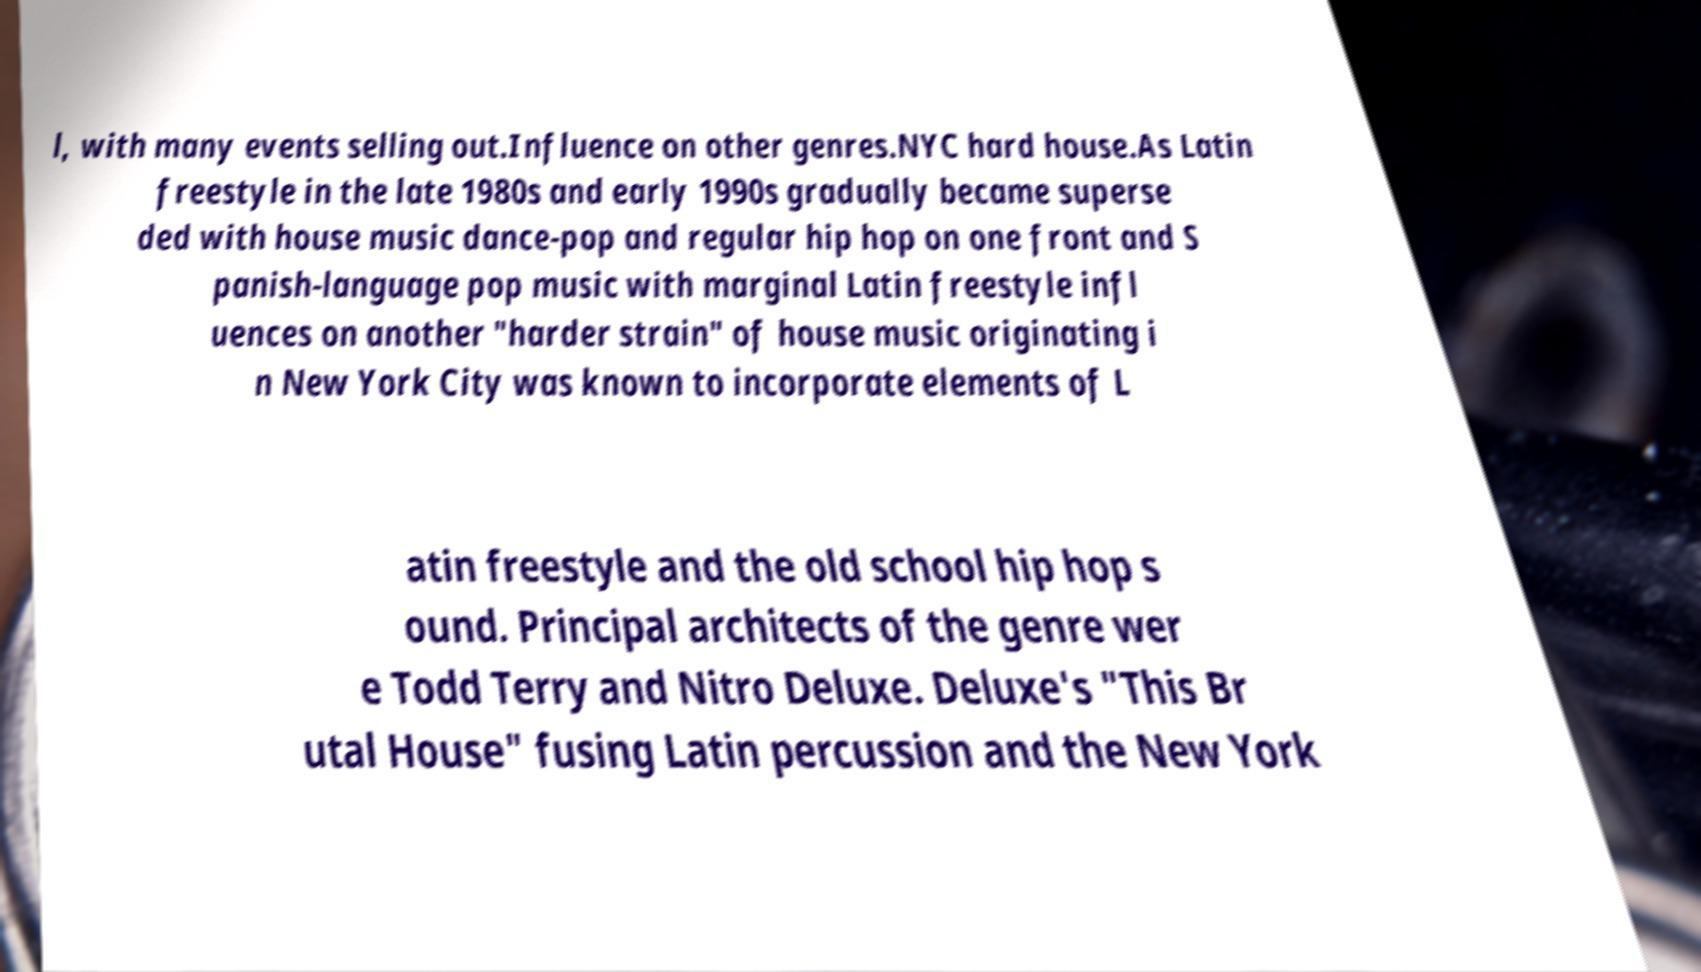I need the written content from this picture converted into text. Can you do that? l, with many events selling out.Influence on other genres.NYC hard house.As Latin freestyle in the late 1980s and early 1990s gradually became superse ded with house music dance-pop and regular hip hop on one front and S panish-language pop music with marginal Latin freestyle infl uences on another "harder strain" of house music originating i n New York City was known to incorporate elements of L atin freestyle and the old school hip hop s ound. Principal architects of the genre wer e Todd Terry and Nitro Deluxe. Deluxe's "This Br utal House" fusing Latin percussion and the New York 